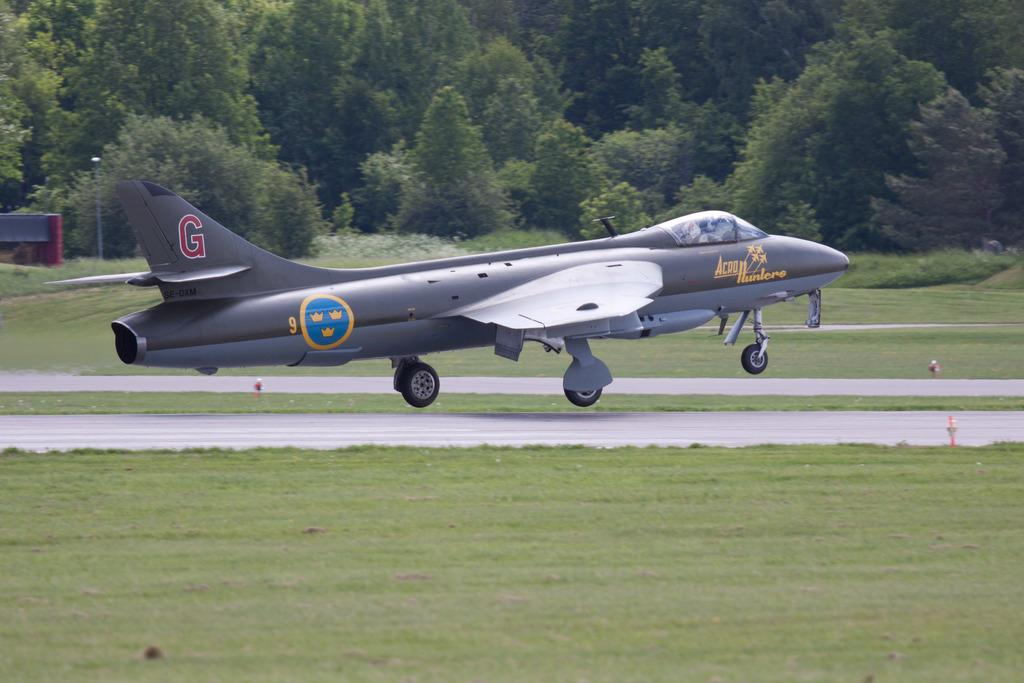<image>
Describe the image concisely. An airplane with the words Acro Hunters written on the side 